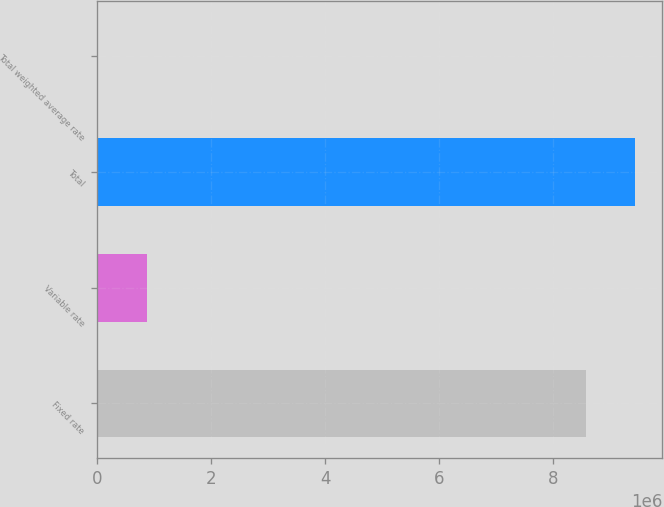Convert chart to OTSL. <chart><loc_0><loc_0><loc_500><loc_500><bar_chart><fcel>Fixed rate<fcel>Variable rate<fcel>Total<fcel>Total weighted average rate<nl><fcel>8.58189e+06<fcel>861589<fcel>9.44347e+06<fcel>5.08<nl></chart> 